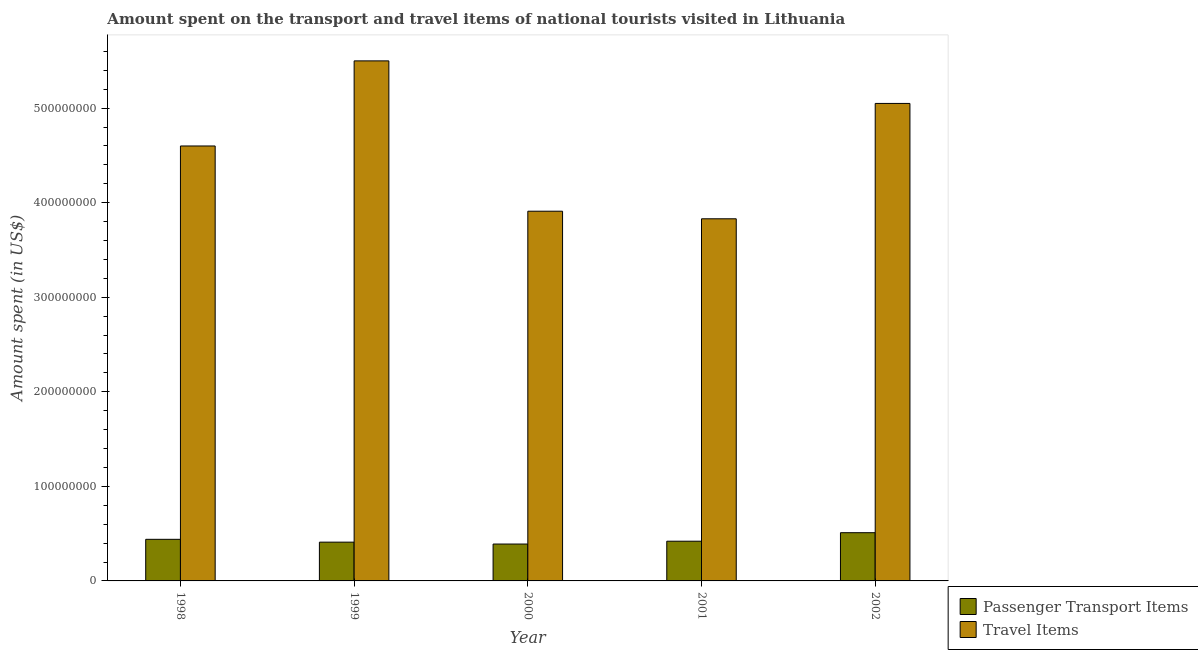How many different coloured bars are there?
Your answer should be very brief. 2. How many groups of bars are there?
Give a very brief answer. 5. How many bars are there on the 5th tick from the left?
Offer a very short reply. 2. What is the label of the 4th group of bars from the left?
Make the answer very short. 2001. In how many cases, is the number of bars for a given year not equal to the number of legend labels?
Your response must be concise. 0. What is the amount spent on passenger transport items in 1999?
Provide a succinct answer. 4.10e+07. Across all years, what is the maximum amount spent on passenger transport items?
Provide a succinct answer. 5.10e+07. Across all years, what is the minimum amount spent on passenger transport items?
Provide a short and direct response. 3.90e+07. What is the total amount spent in travel items in the graph?
Keep it short and to the point. 2.29e+09. What is the difference between the amount spent on passenger transport items in 1998 and that in 1999?
Provide a short and direct response. 3.00e+06. What is the difference between the amount spent in travel items in 2001 and the amount spent on passenger transport items in 1998?
Offer a very short reply. -7.70e+07. What is the average amount spent on passenger transport items per year?
Provide a short and direct response. 4.34e+07. What is the ratio of the amount spent on passenger transport items in 1999 to that in 2001?
Provide a succinct answer. 0.98. Is the amount spent in travel items in 1999 less than that in 2001?
Ensure brevity in your answer.  No. Is the difference between the amount spent on passenger transport items in 1999 and 2002 greater than the difference between the amount spent in travel items in 1999 and 2002?
Make the answer very short. No. What is the difference between the highest and the second highest amount spent in travel items?
Provide a short and direct response. 4.50e+07. What is the difference between the highest and the lowest amount spent on passenger transport items?
Make the answer very short. 1.20e+07. In how many years, is the amount spent on passenger transport items greater than the average amount spent on passenger transport items taken over all years?
Ensure brevity in your answer.  2. What does the 1st bar from the left in 1999 represents?
Give a very brief answer. Passenger Transport Items. What does the 2nd bar from the right in 1998 represents?
Your answer should be compact. Passenger Transport Items. How many years are there in the graph?
Your answer should be very brief. 5. What is the difference between two consecutive major ticks on the Y-axis?
Offer a very short reply. 1.00e+08. Does the graph contain any zero values?
Give a very brief answer. No. How many legend labels are there?
Offer a very short reply. 2. How are the legend labels stacked?
Your answer should be compact. Vertical. What is the title of the graph?
Provide a succinct answer. Amount spent on the transport and travel items of national tourists visited in Lithuania. Does "Stunting" appear as one of the legend labels in the graph?
Offer a very short reply. No. What is the label or title of the X-axis?
Offer a very short reply. Year. What is the label or title of the Y-axis?
Give a very brief answer. Amount spent (in US$). What is the Amount spent (in US$) of Passenger Transport Items in 1998?
Offer a terse response. 4.40e+07. What is the Amount spent (in US$) in Travel Items in 1998?
Provide a succinct answer. 4.60e+08. What is the Amount spent (in US$) of Passenger Transport Items in 1999?
Ensure brevity in your answer.  4.10e+07. What is the Amount spent (in US$) of Travel Items in 1999?
Offer a terse response. 5.50e+08. What is the Amount spent (in US$) of Passenger Transport Items in 2000?
Offer a terse response. 3.90e+07. What is the Amount spent (in US$) in Travel Items in 2000?
Your response must be concise. 3.91e+08. What is the Amount spent (in US$) in Passenger Transport Items in 2001?
Provide a short and direct response. 4.20e+07. What is the Amount spent (in US$) of Travel Items in 2001?
Provide a short and direct response. 3.83e+08. What is the Amount spent (in US$) in Passenger Transport Items in 2002?
Ensure brevity in your answer.  5.10e+07. What is the Amount spent (in US$) of Travel Items in 2002?
Give a very brief answer. 5.05e+08. Across all years, what is the maximum Amount spent (in US$) in Passenger Transport Items?
Offer a very short reply. 5.10e+07. Across all years, what is the maximum Amount spent (in US$) in Travel Items?
Provide a short and direct response. 5.50e+08. Across all years, what is the minimum Amount spent (in US$) of Passenger Transport Items?
Your answer should be very brief. 3.90e+07. Across all years, what is the minimum Amount spent (in US$) of Travel Items?
Make the answer very short. 3.83e+08. What is the total Amount spent (in US$) of Passenger Transport Items in the graph?
Offer a very short reply. 2.17e+08. What is the total Amount spent (in US$) of Travel Items in the graph?
Ensure brevity in your answer.  2.29e+09. What is the difference between the Amount spent (in US$) in Passenger Transport Items in 1998 and that in 1999?
Your answer should be compact. 3.00e+06. What is the difference between the Amount spent (in US$) in Travel Items in 1998 and that in 1999?
Provide a succinct answer. -9.00e+07. What is the difference between the Amount spent (in US$) in Travel Items in 1998 and that in 2000?
Offer a terse response. 6.90e+07. What is the difference between the Amount spent (in US$) of Travel Items in 1998 and that in 2001?
Keep it short and to the point. 7.70e+07. What is the difference between the Amount spent (in US$) of Passenger Transport Items in 1998 and that in 2002?
Offer a very short reply. -7.00e+06. What is the difference between the Amount spent (in US$) of Travel Items in 1998 and that in 2002?
Your response must be concise. -4.50e+07. What is the difference between the Amount spent (in US$) of Travel Items in 1999 and that in 2000?
Provide a succinct answer. 1.59e+08. What is the difference between the Amount spent (in US$) of Passenger Transport Items in 1999 and that in 2001?
Your answer should be compact. -1.00e+06. What is the difference between the Amount spent (in US$) of Travel Items in 1999 and that in 2001?
Provide a short and direct response. 1.67e+08. What is the difference between the Amount spent (in US$) of Passenger Transport Items in 1999 and that in 2002?
Offer a very short reply. -1.00e+07. What is the difference between the Amount spent (in US$) of Travel Items in 1999 and that in 2002?
Give a very brief answer. 4.50e+07. What is the difference between the Amount spent (in US$) of Passenger Transport Items in 2000 and that in 2002?
Provide a succinct answer. -1.20e+07. What is the difference between the Amount spent (in US$) of Travel Items in 2000 and that in 2002?
Keep it short and to the point. -1.14e+08. What is the difference between the Amount spent (in US$) of Passenger Transport Items in 2001 and that in 2002?
Offer a terse response. -9.00e+06. What is the difference between the Amount spent (in US$) of Travel Items in 2001 and that in 2002?
Your response must be concise. -1.22e+08. What is the difference between the Amount spent (in US$) in Passenger Transport Items in 1998 and the Amount spent (in US$) in Travel Items in 1999?
Offer a very short reply. -5.06e+08. What is the difference between the Amount spent (in US$) in Passenger Transport Items in 1998 and the Amount spent (in US$) in Travel Items in 2000?
Your answer should be very brief. -3.47e+08. What is the difference between the Amount spent (in US$) in Passenger Transport Items in 1998 and the Amount spent (in US$) in Travel Items in 2001?
Make the answer very short. -3.39e+08. What is the difference between the Amount spent (in US$) in Passenger Transport Items in 1998 and the Amount spent (in US$) in Travel Items in 2002?
Provide a short and direct response. -4.61e+08. What is the difference between the Amount spent (in US$) of Passenger Transport Items in 1999 and the Amount spent (in US$) of Travel Items in 2000?
Give a very brief answer. -3.50e+08. What is the difference between the Amount spent (in US$) in Passenger Transport Items in 1999 and the Amount spent (in US$) in Travel Items in 2001?
Offer a terse response. -3.42e+08. What is the difference between the Amount spent (in US$) in Passenger Transport Items in 1999 and the Amount spent (in US$) in Travel Items in 2002?
Provide a succinct answer. -4.64e+08. What is the difference between the Amount spent (in US$) in Passenger Transport Items in 2000 and the Amount spent (in US$) in Travel Items in 2001?
Offer a terse response. -3.44e+08. What is the difference between the Amount spent (in US$) of Passenger Transport Items in 2000 and the Amount spent (in US$) of Travel Items in 2002?
Offer a very short reply. -4.66e+08. What is the difference between the Amount spent (in US$) in Passenger Transport Items in 2001 and the Amount spent (in US$) in Travel Items in 2002?
Ensure brevity in your answer.  -4.63e+08. What is the average Amount spent (in US$) of Passenger Transport Items per year?
Your answer should be very brief. 4.34e+07. What is the average Amount spent (in US$) of Travel Items per year?
Ensure brevity in your answer.  4.58e+08. In the year 1998, what is the difference between the Amount spent (in US$) in Passenger Transport Items and Amount spent (in US$) in Travel Items?
Make the answer very short. -4.16e+08. In the year 1999, what is the difference between the Amount spent (in US$) in Passenger Transport Items and Amount spent (in US$) in Travel Items?
Offer a terse response. -5.09e+08. In the year 2000, what is the difference between the Amount spent (in US$) of Passenger Transport Items and Amount spent (in US$) of Travel Items?
Your answer should be very brief. -3.52e+08. In the year 2001, what is the difference between the Amount spent (in US$) in Passenger Transport Items and Amount spent (in US$) in Travel Items?
Provide a short and direct response. -3.41e+08. In the year 2002, what is the difference between the Amount spent (in US$) of Passenger Transport Items and Amount spent (in US$) of Travel Items?
Keep it short and to the point. -4.54e+08. What is the ratio of the Amount spent (in US$) of Passenger Transport Items in 1998 to that in 1999?
Offer a very short reply. 1.07. What is the ratio of the Amount spent (in US$) in Travel Items in 1998 to that in 1999?
Your response must be concise. 0.84. What is the ratio of the Amount spent (in US$) in Passenger Transport Items in 1998 to that in 2000?
Your answer should be compact. 1.13. What is the ratio of the Amount spent (in US$) in Travel Items in 1998 to that in 2000?
Ensure brevity in your answer.  1.18. What is the ratio of the Amount spent (in US$) of Passenger Transport Items in 1998 to that in 2001?
Provide a succinct answer. 1.05. What is the ratio of the Amount spent (in US$) in Travel Items in 1998 to that in 2001?
Give a very brief answer. 1.2. What is the ratio of the Amount spent (in US$) in Passenger Transport Items in 1998 to that in 2002?
Provide a short and direct response. 0.86. What is the ratio of the Amount spent (in US$) of Travel Items in 1998 to that in 2002?
Ensure brevity in your answer.  0.91. What is the ratio of the Amount spent (in US$) in Passenger Transport Items in 1999 to that in 2000?
Your answer should be compact. 1.05. What is the ratio of the Amount spent (in US$) in Travel Items in 1999 to that in 2000?
Your answer should be compact. 1.41. What is the ratio of the Amount spent (in US$) in Passenger Transport Items in 1999 to that in 2001?
Your response must be concise. 0.98. What is the ratio of the Amount spent (in US$) of Travel Items in 1999 to that in 2001?
Your answer should be very brief. 1.44. What is the ratio of the Amount spent (in US$) of Passenger Transport Items in 1999 to that in 2002?
Offer a very short reply. 0.8. What is the ratio of the Amount spent (in US$) of Travel Items in 1999 to that in 2002?
Offer a terse response. 1.09. What is the ratio of the Amount spent (in US$) in Passenger Transport Items in 2000 to that in 2001?
Your answer should be compact. 0.93. What is the ratio of the Amount spent (in US$) of Travel Items in 2000 to that in 2001?
Give a very brief answer. 1.02. What is the ratio of the Amount spent (in US$) in Passenger Transport Items in 2000 to that in 2002?
Keep it short and to the point. 0.76. What is the ratio of the Amount spent (in US$) in Travel Items in 2000 to that in 2002?
Your response must be concise. 0.77. What is the ratio of the Amount spent (in US$) of Passenger Transport Items in 2001 to that in 2002?
Your response must be concise. 0.82. What is the ratio of the Amount spent (in US$) in Travel Items in 2001 to that in 2002?
Your answer should be very brief. 0.76. What is the difference between the highest and the second highest Amount spent (in US$) in Passenger Transport Items?
Make the answer very short. 7.00e+06. What is the difference between the highest and the second highest Amount spent (in US$) of Travel Items?
Offer a terse response. 4.50e+07. What is the difference between the highest and the lowest Amount spent (in US$) of Passenger Transport Items?
Ensure brevity in your answer.  1.20e+07. What is the difference between the highest and the lowest Amount spent (in US$) in Travel Items?
Give a very brief answer. 1.67e+08. 